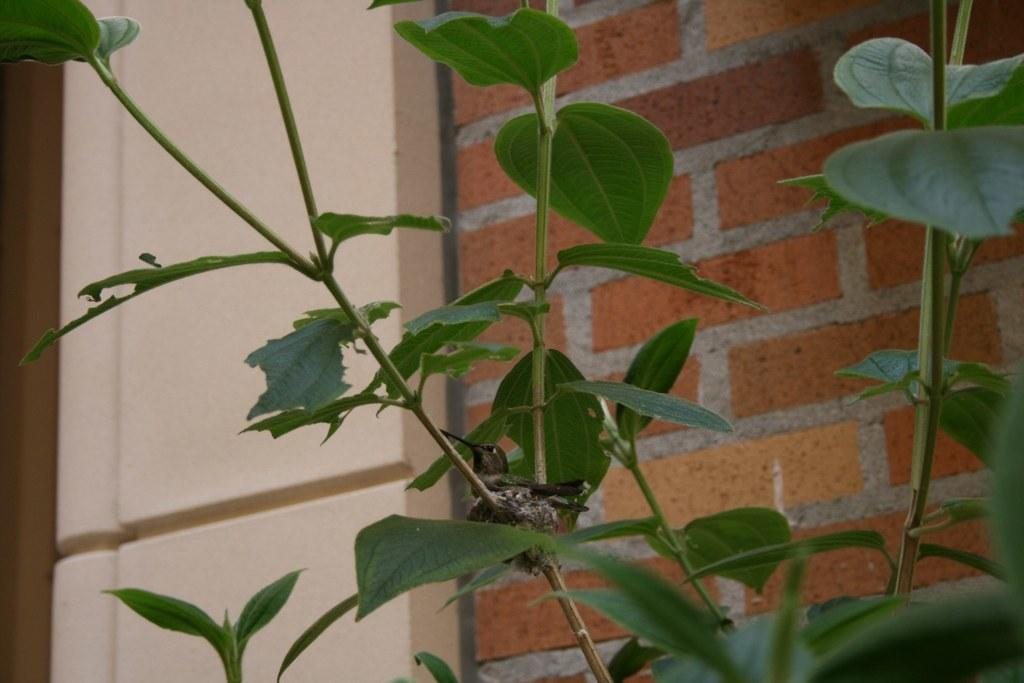What type of animal can be seen in the image? There is a bird in the image. Where is the bird located? The bird is on a plant. What else can be seen in the background of the image? There is a wall visible in the image. How many bikes are parked near the bird in the image? There are no bikes present in the image; it features a bird on a plant and a wall in the background. What type of mask is the bird wearing in the image? There is no mask present on the bird in the image; it is simply a bird on a plant. 